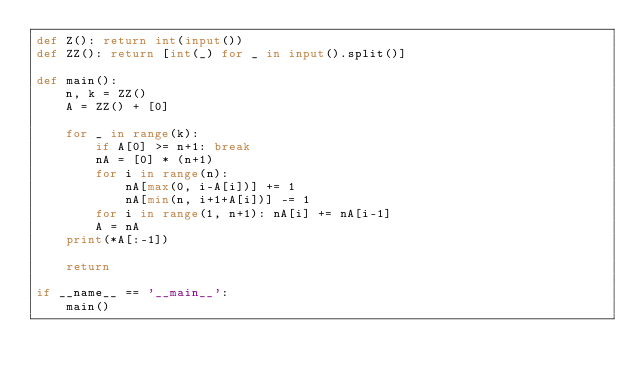Convert code to text. <code><loc_0><loc_0><loc_500><loc_500><_Python_>def Z(): return int(input())
def ZZ(): return [int(_) for _ in input().split()]

def main():
    n, k = ZZ()
    A = ZZ() + [0]

    for _ in range(k):
        if A[0] >= n+1: break
        nA = [0] * (n+1)
        for i in range(n):
            nA[max(0, i-A[i])] += 1
            nA[min(n, i+1+A[i])] -= 1
        for i in range(1, n+1): nA[i] += nA[i-1]
        A = nA
    print(*A[:-1])

    return

if __name__ == '__main__':
    main()
</code> 